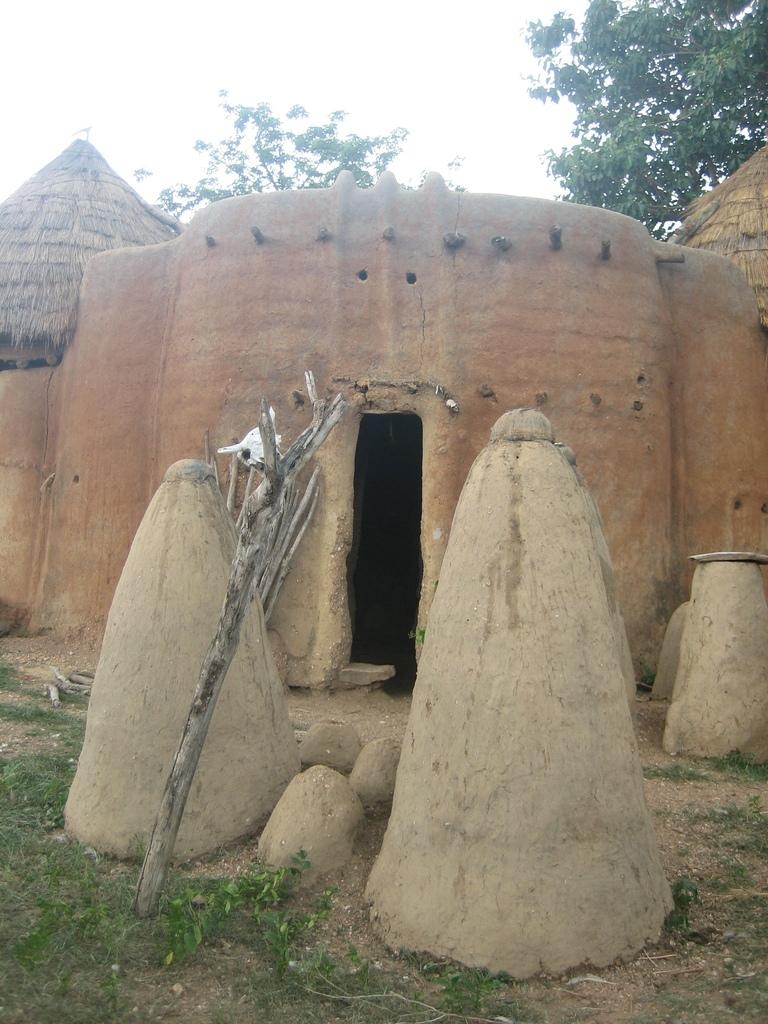What type of structure is visible in the image? There is a house in the image. What materials are used for the poles in the image? The poles in the image are made of wood. What type of natural elements can be seen in the image? Stones, grass, plants, trees, and the sky are visible in the image. What type of religious symbol can be seen in the image? There is no religious symbol present in the image. Can you describe the ghost that is visible in the image? There is no ghost visible in the image. 